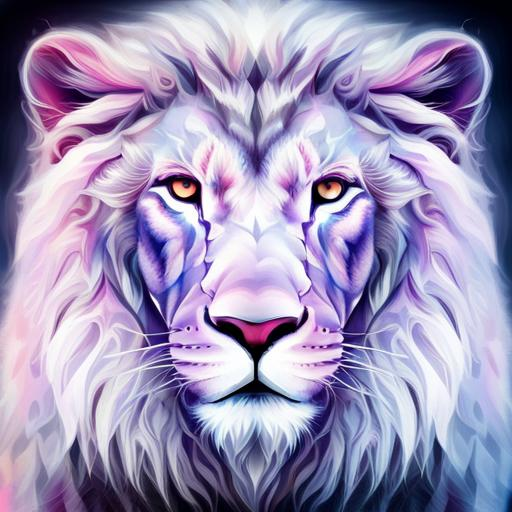What is the subject of the image?
A. giraffe
B. elephant
C. tiger While the given answer was 'C. tiger,' the subject of the image is neither a giraffe, an elephant, nor a tiger. Instead, the image presents an artistically rendered depiction of a lion, characterized by vibrant and colorful detailing that is not typically found in nature. This indicates that the artwork is likely a digital creation or a stylized interpretation rather than a realistic representation of a lion. 